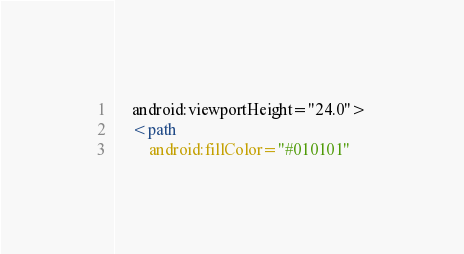<code> <loc_0><loc_0><loc_500><loc_500><_XML_>    android:viewportHeight="24.0">
    <path
        android:fillColor="#010101"</code> 